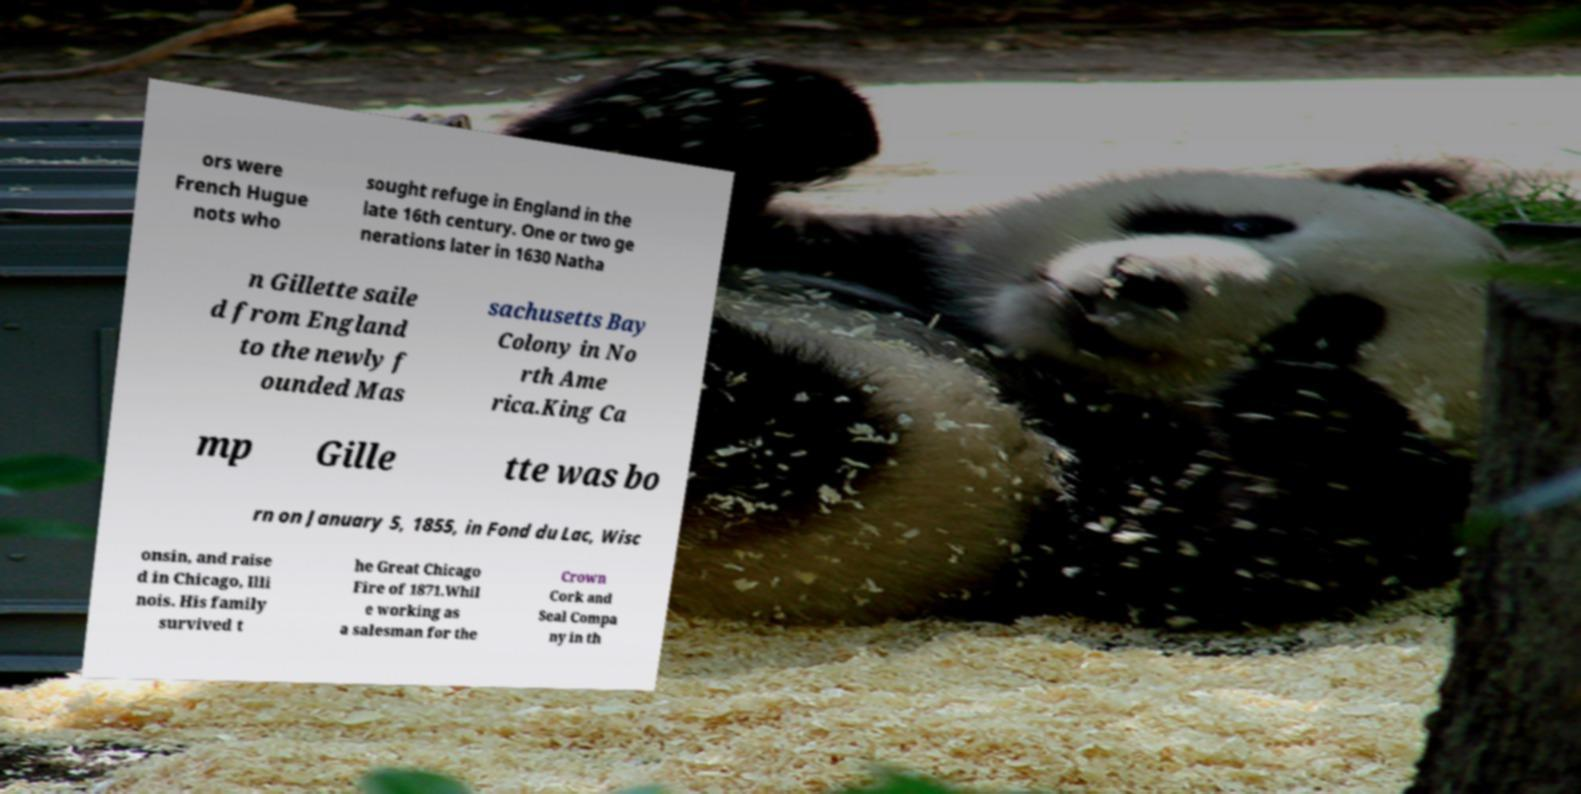Please read and relay the text visible in this image. What does it say? ors were French Hugue nots who sought refuge in England in the late 16th century. One or two ge nerations later in 1630 Natha n Gillette saile d from England to the newly f ounded Mas sachusetts Bay Colony in No rth Ame rica.King Ca mp Gille tte was bo rn on January 5, 1855, in Fond du Lac, Wisc onsin, and raise d in Chicago, Illi nois. His family survived t he Great Chicago Fire of 1871.Whil e working as a salesman for the Crown Cork and Seal Compa ny in th 